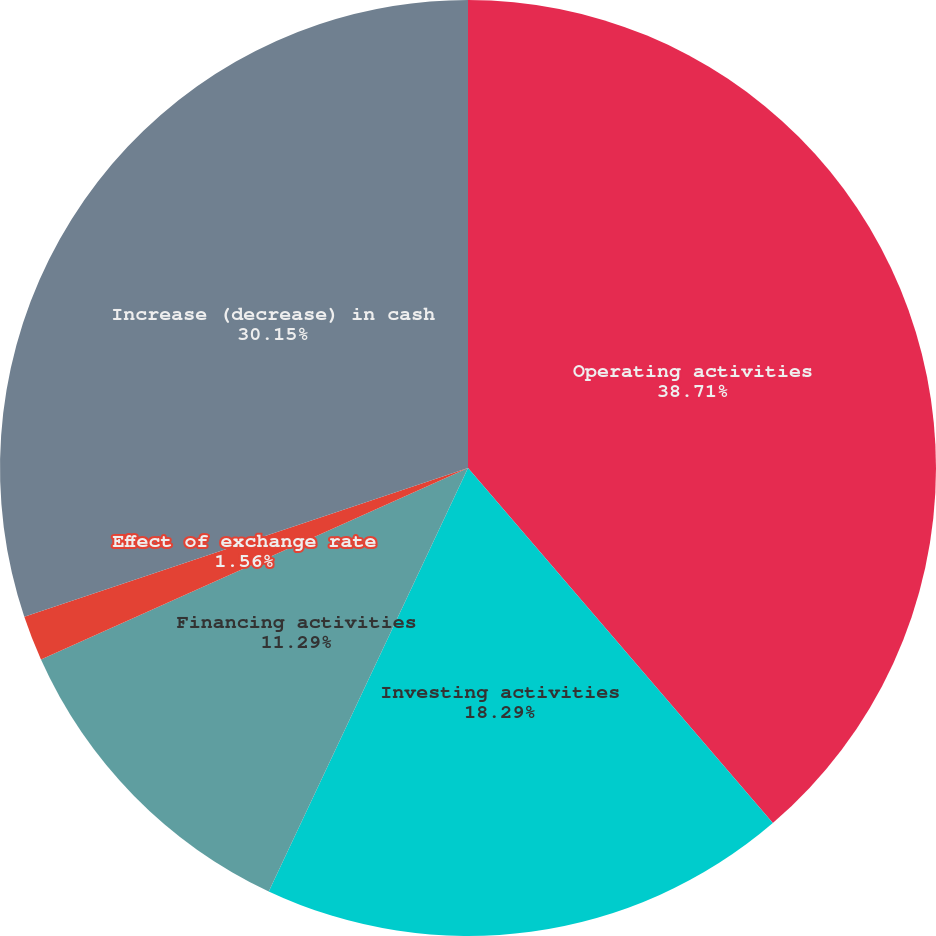Convert chart to OTSL. <chart><loc_0><loc_0><loc_500><loc_500><pie_chart><fcel>Operating activities<fcel>Investing activities<fcel>Financing activities<fcel>Effect of exchange rate<fcel>Increase (decrease) in cash<nl><fcel>38.71%<fcel>18.29%<fcel>11.29%<fcel>1.56%<fcel>30.15%<nl></chart> 